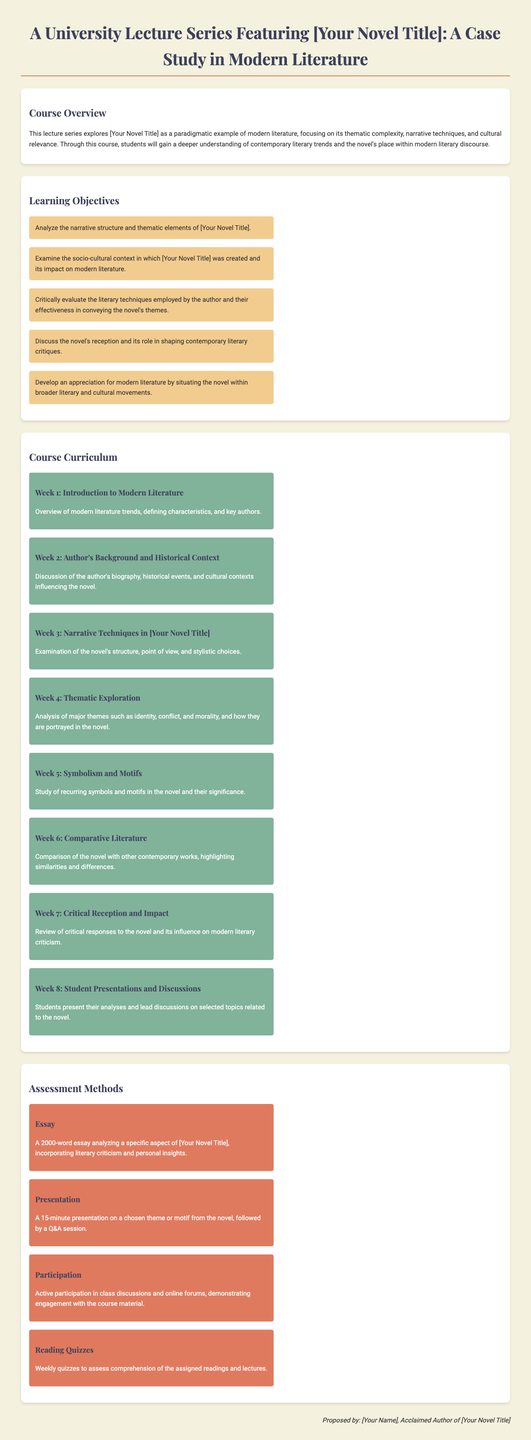What is the title of the lecture series? The title of the lecture series is stated clearly at the beginning of the document, featuring "[Your Novel Title]."
Answer: A University Lecture Series Featuring [Your Novel Title] How many learning objectives are listed? The section on learning objectives outlines a total of five objectives for the course.
Answer: 5 What theme is explored in Week 4? Week 4 focuses specifically on analyzing major themes of the novel, particularly identity, conflict, and morality.
Answer: Thematic Exploration What is the word count for the essay assignment? The document specifies that the essay assignment should be 2000 words analyzing an aspect of the novel.
Answer: 2000-word What type of assessment includes group interaction? The method of assessment that involves engagement and discussion among students is reflected in the participation criteria.
Answer: Participation What is the duration of the presentations? The presentations described in the assessment methods section are specified to last for 15 minutes.
Answer: 15-minute In which week do student presentations occur? Week 8 is designated for student presentations and discussions related to the novel.
Answer: Week 8 Who proposed the lecture series? The proposal is signed by the author, which is credited to "[Your Name]."
Answer: [Your Name] 